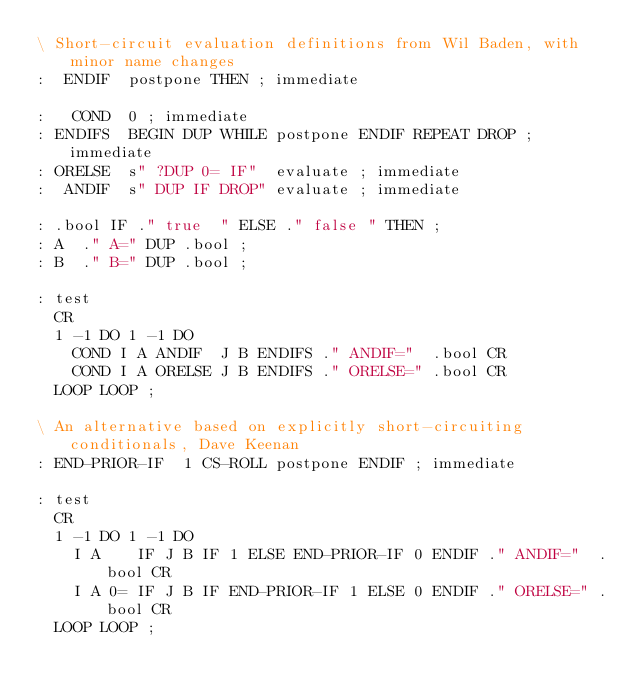<code> <loc_0><loc_0><loc_500><loc_500><_Forth_>\ Short-circuit evaluation definitions from Wil Baden, with minor name changes
:  ENDIF  postpone THEN ; immediate

:   COND  0 ; immediate
: ENDIFS  BEGIN DUP WHILE postpone ENDIF REPEAT DROP ; immediate
: ORELSE  s" ?DUP 0= IF"  evaluate ; immediate
:  ANDIF  s" DUP IF DROP" evaluate ; immediate

: .bool IF ." true  " ELSE ." false " THEN ;
: A  ." A=" DUP .bool ;
: B  ." B=" DUP .bool ;

: test
  CR
  1 -1 DO 1 -1 DO
    COND I A ANDIF  J B ENDIFS ." ANDIF="  .bool CR
    COND I A ORELSE J B ENDIFS ." ORELSE=" .bool CR
  LOOP LOOP ;

\ An alternative based on explicitly short-circuiting conditionals, Dave Keenan
: END-PRIOR-IF  1 CS-ROLL postpone ENDIF ; immediate

: test
  CR
  1 -1 DO 1 -1 DO
    I A    IF J B IF 1 ELSE END-PRIOR-IF 0 ENDIF ." ANDIF="  .bool CR
    I A 0= IF J B IF END-PRIOR-IF 1 ELSE 0 ENDIF ." ORELSE=" .bool CR
  LOOP LOOP ;
</code> 